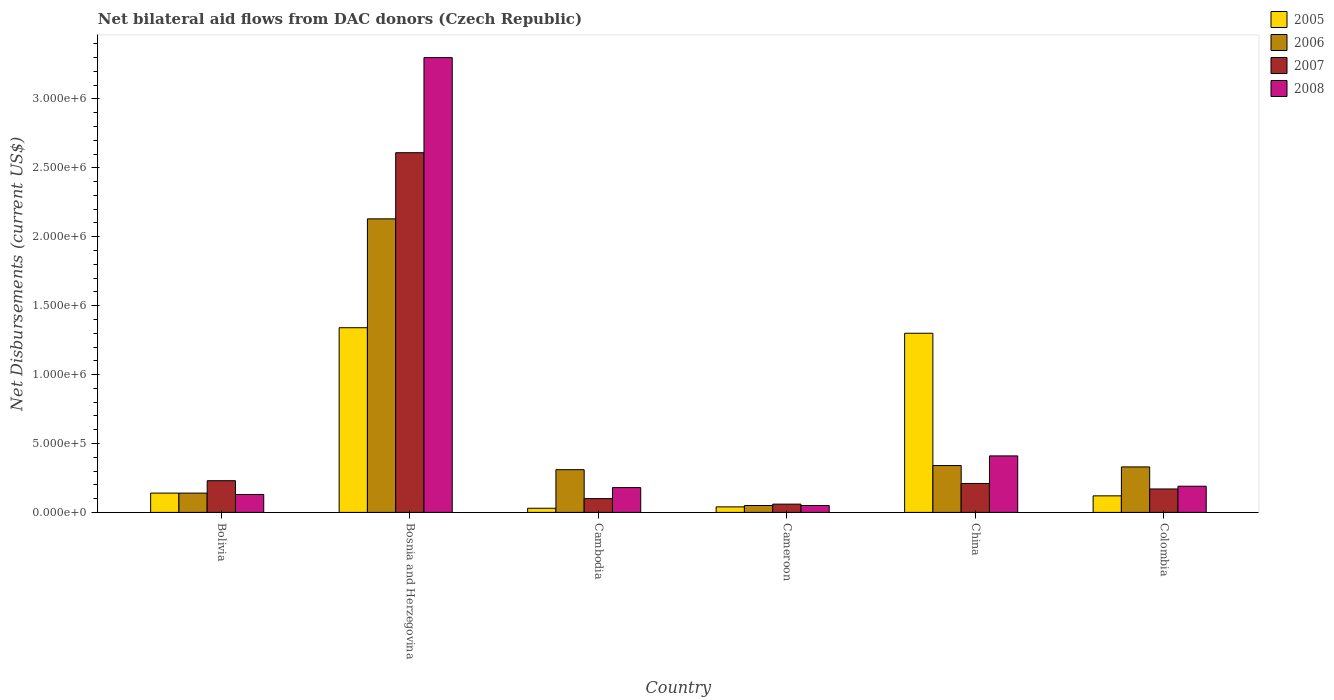How many different coloured bars are there?
Offer a very short reply. 4. How many groups of bars are there?
Your answer should be compact. 6. Are the number of bars per tick equal to the number of legend labels?
Make the answer very short. Yes. Are the number of bars on each tick of the X-axis equal?
Provide a short and direct response. Yes. What is the label of the 2nd group of bars from the left?
Your answer should be compact. Bosnia and Herzegovina. In how many cases, is the number of bars for a given country not equal to the number of legend labels?
Your answer should be compact. 0. What is the net bilateral aid flows in 2007 in Bolivia?
Keep it short and to the point. 2.30e+05. Across all countries, what is the maximum net bilateral aid flows in 2005?
Your answer should be very brief. 1.34e+06. In which country was the net bilateral aid flows in 2006 maximum?
Offer a very short reply. Bosnia and Herzegovina. In which country was the net bilateral aid flows in 2006 minimum?
Offer a very short reply. Cameroon. What is the total net bilateral aid flows in 2007 in the graph?
Offer a terse response. 3.38e+06. What is the difference between the net bilateral aid flows in 2007 in Cambodia and the net bilateral aid flows in 2006 in Bolivia?
Offer a terse response. -4.00e+04. What is the average net bilateral aid flows in 2008 per country?
Provide a short and direct response. 7.10e+05. In how many countries, is the net bilateral aid flows in 2008 greater than 700000 US$?
Provide a short and direct response. 1. What is the ratio of the net bilateral aid flows in 2008 in Cambodia to that in Colombia?
Make the answer very short. 0.95. Is the difference between the net bilateral aid flows in 2008 in Bolivia and Colombia greater than the difference between the net bilateral aid flows in 2007 in Bolivia and Colombia?
Offer a terse response. No. What is the difference between the highest and the second highest net bilateral aid flows in 2006?
Provide a succinct answer. 1.80e+06. What is the difference between the highest and the lowest net bilateral aid flows in 2008?
Offer a terse response. 3.25e+06. In how many countries, is the net bilateral aid flows in 2008 greater than the average net bilateral aid flows in 2008 taken over all countries?
Your answer should be very brief. 1. Is the sum of the net bilateral aid flows in 2006 in Bosnia and Herzegovina and China greater than the maximum net bilateral aid flows in 2007 across all countries?
Provide a short and direct response. No. What does the 3rd bar from the left in Cambodia represents?
Ensure brevity in your answer.  2007. Is it the case that in every country, the sum of the net bilateral aid flows in 2007 and net bilateral aid flows in 2006 is greater than the net bilateral aid flows in 2008?
Keep it short and to the point. Yes. How many bars are there?
Give a very brief answer. 24. Are all the bars in the graph horizontal?
Provide a short and direct response. No. How many countries are there in the graph?
Provide a succinct answer. 6. What is the difference between two consecutive major ticks on the Y-axis?
Make the answer very short. 5.00e+05. Does the graph contain any zero values?
Your response must be concise. No. How many legend labels are there?
Give a very brief answer. 4. How are the legend labels stacked?
Keep it short and to the point. Vertical. What is the title of the graph?
Provide a short and direct response. Net bilateral aid flows from DAC donors (Czech Republic). What is the label or title of the X-axis?
Make the answer very short. Country. What is the label or title of the Y-axis?
Provide a succinct answer. Net Disbursements (current US$). What is the Net Disbursements (current US$) of 2005 in Bolivia?
Make the answer very short. 1.40e+05. What is the Net Disbursements (current US$) of 2007 in Bolivia?
Offer a terse response. 2.30e+05. What is the Net Disbursements (current US$) of 2005 in Bosnia and Herzegovina?
Provide a short and direct response. 1.34e+06. What is the Net Disbursements (current US$) in 2006 in Bosnia and Herzegovina?
Your answer should be compact. 2.13e+06. What is the Net Disbursements (current US$) in 2007 in Bosnia and Herzegovina?
Give a very brief answer. 2.61e+06. What is the Net Disbursements (current US$) in 2008 in Bosnia and Herzegovina?
Ensure brevity in your answer.  3.30e+06. What is the Net Disbursements (current US$) in 2005 in Cambodia?
Provide a succinct answer. 3.00e+04. What is the Net Disbursements (current US$) in 2006 in Cambodia?
Your response must be concise. 3.10e+05. What is the Net Disbursements (current US$) in 2007 in Cambodia?
Ensure brevity in your answer.  1.00e+05. What is the Net Disbursements (current US$) of 2007 in Cameroon?
Your response must be concise. 6.00e+04. What is the Net Disbursements (current US$) in 2008 in Cameroon?
Your answer should be compact. 5.00e+04. What is the Net Disbursements (current US$) in 2005 in China?
Make the answer very short. 1.30e+06. What is the Net Disbursements (current US$) of 2007 in China?
Keep it short and to the point. 2.10e+05. What is the Net Disbursements (current US$) of 2007 in Colombia?
Offer a very short reply. 1.70e+05. What is the Net Disbursements (current US$) of 2008 in Colombia?
Keep it short and to the point. 1.90e+05. Across all countries, what is the maximum Net Disbursements (current US$) of 2005?
Offer a terse response. 1.34e+06. Across all countries, what is the maximum Net Disbursements (current US$) of 2006?
Offer a very short reply. 2.13e+06. Across all countries, what is the maximum Net Disbursements (current US$) of 2007?
Keep it short and to the point. 2.61e+06. Across all countries, what is the maximum Net Disbursements (current US$) of 2008?
Provide a succinct answer. 3.30e+06. Across all countries, what is the minimum Net Disbursements (current US$) in 2006?
Your response must be concise. 5.00e+04. Across all countries, what is the minimum Net Disbursements (current US$) in 2008?
Your response must be concise. 5.00e+04. What is the total Net Disbursements (current US$) in 2005 in the graph?
Offer a terse response. 2.97e+06. What is the total Net Disbursements (current US$) of 2006 in the graph?
Your response must be concise. 3.30e+06. What is the total Net Disbursements (current US$) in 2007 in the graph?
Your response must be concise. 3.38e+06. What is the total Net Disbursements (current US$) of 2008 in the graph?
Your answer should be compact. 4.26e+06. What is the difference between the Net Disbursements (current US$) of 2005 in Bolivia and that in Bosnia and Herzegovina?
Make the answer very short. -1.20e+06. What is the difference between the Net Disbursements (current US$) in 2006 in Bolivia and that in Bosnia and Herzegovina?
Ensure brevity in your answer.  -1.99e+06. What is the difference between the Net Disbursements (current US$) of 2007 in Bolivia and that in Bosnia and Herzegovina?
Your response must be concise. -2.38e+06. What is the difference between the Net Disbursements (current US$) of 2008 in Bolivia and that in Bosnia and Herzegovina?
Your answer should be compact. -3.17e+06. What is the difference between the Net Disbursements (current US$) of 2005 in Bolivia and that in Cambodia?
Your answer should be compact. 1.10e+05. What is the difference between the Net Disbursements (current US$) of 2007 in Bolivia and that in Cambodia?
Provide a short and direct response. 1.30e+05. What is the difference between the Net Disbursements (current US$) of 2008 in Bolivia and that in Cambodia?
Make the answer very short. -5.00e+04. What is the difference between the Net Disbursements (current US$) in 2005 in Bolivia and that in Cameroon?
Keep it short and to the point. 1.00e+05. What is the difference between the Net Disbursements (current US$) in 2008 in Bolivia and that in Cameroon?
Offer a terse response. 8.00e+04. What is the difference between the Net Disbursements (current US$) of 2005 in Bolivia and that in China?
Provide a succinct answer. -1.16e+06. What is the difference between the Net Disbursements (current US$) of 2008 in Bolivia and that in China?
Your answer should be compact. -2.80e+05. What is the difference between the Net Disbursements (current US$) of 2005 in Bolivia and that in Colombia?
Keep it short and to the point. 2.00e+04. What is the difference between the Net Disbursements (current US$) of 2006 in Bolivia and that in Colombia?
Your answer should be compact. -1.90e+05. What is the difference between the Net Disbursements (current US$) in 2005 in Bosnia and Herzegovina and that in Cambodia?
Ensure brevity in your answer.  1.31e+06. What is the difference between the Net Disbursements (current US$) in 2006 in Bosnia and Herzegovina and that in Cambodia?
Your answer should be very brief. 1.82e+06. What is the difference between the Net Disbursements (current US$) of 2007 in Bosnia and Herzegovina and that in Cambodia?
Keep it short and to the point. 2.51e+06. What is the difference between the Net Disbursements (current US$) in 2008 in Bosnia and Herzegovina and that in Cambodia?
Give a very brief answer. 3.12e+06. What is the difference between the Net Disbursements (current US$) of 2005 in Bosnia and Herzegovina and that in Cameroon?
Keep it short and to the point. 1.30e+06. What is the difference between the Net Disbursements (current US$) of 2006 in Bosnia and Herzegovina and that in Cameroon?
Your response must be concise. 2.08e+06. What is the difference between the Net Disbursements (current US$) of 2007 in Bosnia and Herzegovina and that in Cameroon?
Provide a succinct answer. 2.55e+06. What is the difference between the Net Disbursements (current US$) of 2008 in Bosnia and Herzegovina and that in Cameroon?
Give a very brief answer. 3.25e+06. What is the difference between the Net Disbursements (current US$) in 2005 in Bosnia and Herzegovina and that in China?
Your answer should be compact. 4.00e+04. What is the difference between the Net Disbursements (current US$) of 2006 in Bosnia and Herzegovina and that in China?
Offer a terse response. 1.79e+06. What is the difference between the Net Disbursements (current US$) in 2007 in Bosnia and Herzegovina and that in China?
Offer a very short reply. 2.40e+06. What is the difference between the Net Disbursements (current US$) of 2008 in Bosnia and Herzegovina and that in China?
Provide a succinct answer. 2.89e+06. What is the difference between the Net Disbursements (current US$) in 2005 in Bosnia and Herzegovina and that in Colombia?
Ensure brevity in your answer.  1.22e+06. What is the difference between the Net Disbursements (current US$) in 2006 in Bosnia and Herzegovina and that in Colombia?
Provide a succinct answer. 1.80e+06. What is the difference between the Net Disbursements (current US$) in 2007 in Bosnia and Herzegovina and that in Colombia?
Keep it short and to the point. 2.44e+06. What is the difference between the Net Disbursements (current US$) of 2008 in Bosnia and Herzegovina and that in Colombia?
Offer a very short reply. 3.11e+06. What is the difference between the Net Disbursements (current US$) in 2005 in Cambodia and that in Cameroon?
Keep it short and to the point. -10000. What is the difference between the Net Disbursements (current US$) of 2007 in Cambodia and that in Cameroon?
Your answer should be very brief. 4.00e+04. What is the difference between the Net Disbursements (current US$) of 2008 in Cambodia and that in Cameroon?
Your answer should be very brief. 1.30e+05. What is the difference between the Net Disbursements (current US$) of 2005 in Cambodia and that in China?
Your response must be concise. -1.27e+06. What is the difference between the Net Disbursements (current US$) in 2006 in Cambodia and that in China?
Make the answer very short. -3.00e+04. What is the difference between the Net Disbursements (current US$) in 2008 in Cambodia and that in China?
Your answer should be compact. -2.30e+05. What is the difference between the Net Disbursements (current US$) of 2005 in Cambodia and that in Colombia?
Your response must be concise. -9.00e+04. What is the difference between the Net Disbursements (current US$) of 2008 in Cambodia and that in Colombia?
Ensure brevity in your answer.  -10000. What is the difference between the Net Disbursements (current US$) in 2005 in Cameroon and that in China?
Your response must be concise. -1.26e+06. What is the difference between the Net Disbursements (current US$) of 2008 in Cameroon and that in China?
Make the answer very short. -3.60e+05. What is the difference between the Net Disbursements (current US$) of 2006 in Cameroon and that in Colombia?
Ensure brevity in your answer.  -2.80e+05. What is the difference between the Net Disbursements (current US$) in 2007 in Cameroon and that in Colombia?
Keep it short and to the point. -1.10e+05. What is the difference between the Net Disbursements (current US$) in 2005 in China and that in Colombia?
Ensure brevity in your answer.  1.18e+06. What is the difference between the Net Disbursements (current US$) of 2006 in China and that in Colombia?
Your answer should be compact. 10000. What is the difference between the Net Disbursements (current US$) in 2005 in Bolivia and the Net Disbursements (current US$) in 2006 in Bosnia and Herzegovina?
Give a very brief answer. -1.99e+06. What is the difference between the Net Disbursements (current US$) in 2005 in Bolivia and the Net Disbursements (current US$) in 2007 in Bosnia and Herzegovina?
Keep it short and to the point. -2.47e+06. What is the difference between the Net Disbursements (current US$) in 2005 in Bolivia and the Net Disbursements (current US$) in 2008 in Bosnia and Herzegovina?
Your answer should be very brief. -3.16e+06. What is the difference between the Net Disbursements (current US$) of 2006 in Bolivia and the Net Disbursements (current US$) of 2007 in Bosnia and Herzegovina?
Provide a succinct answer. -2.47e+06. What is the difference between the Net Disbursements (current US$) of 2006 in Bolivia and the Net Disbursements (current US$) of 2008 in Bosnia and Herzegovina?
Make the answer very short. -3.16e+06. What is the difference between the Net Disbursements (current US$) of 2007 in Bolivia and the Net Disbursements (current US$) of 2008 in Bosnia and Herzegovina?
Offer a very short reply. -3.07e+06. What is the difference between the Net Disbursements (current US$) in 2005 in Bolivia and the Net Disbursements (current US$) in 2007 in Cambodia?
Keep it short and to the point. 4.00e+04. What is the difference between the Net Disbursements (current US$) of 2005 in Bolivia and the Net Disbursements (current US$) of 2008 in Cambodia?
Make the answer very short. -4.00e+04. What is the difference between the Net Disbursements (current US$) in 2006 in Bolivia and the Net Disbursements (current US$) in 2008 in Cambodia?
Provide a succinct answer. -4.00e+04. What is the difference between the Net Disbursements (current US$) of 2006 in Bolivia and the Net Disbursements (current US$) of 2008 in Cameroon?
Your answer should be compact. 9.00e+04. What is the difference between the Net Disbursements (current US$) in 2007 in Bolivia and the Net Disbursements (current US$) in 2008 in Cameroon?
Your answer should be very brief. 1.80e+05. What is the difference between the Net Disbursements (current US$) of 2005 in Bolivia and the Net Disbursements (current US$) of 2008 in China?
Give a very brief answer. -2.70e+05. What is the difference between the Net Disbursements (current US$) of 2006 in Bolivia and the Net Disbursements (current US$) of 2008 in China?
Your answer should be very brief. -2.70e+05. What is the difference between the Net Disbursements (current US$) of 2007 in Bolivia and the Net Disbursements (current US$) of 2008 in China?
Keep it short and to the point. -1.80e+05. What is the difference between the Net Disbursements (current US$) in 2005 in Bolivia and the Net Disbursements (current US$) in 2006 in Colombia?
Provide a short and direct response. -1.90e+05. What is the difference between the Net Disbursements (current US$) in 2005 in Bolivia and the Net Disbursements (current US$) in 2007 in Colombia?
Offer a very short reply. -3.00e+04. What is the difference between the Net Disbursements (current US$) of 2005 in Bolivia and the Net Disbursements (current US$) of 2008 in Colombia?
Your answer should be compact. -5.00e+04. What is the difference between the Net Disbursements (current US$) in 2005 in Bosnia and Herzegovina and the Net Disbursements (current US$) in 2006 in Cambodia?
Provide a succinct answer. 1.03e+06. What is the difference between the Net Disbursements (current US$) of 2005 in Bosnia and Herzegovina and the Net Disbursements (current US$) of 2007 in Cambodia?
Offer a very short reply. 1.24e+06. What is the difference between the Net Disbursements (current US$) in 2005 in Bosnia and Herzegovina and the Net Disbursements (current US$) in 2008 in Cambodia?
Offer a terse response. 1.16e+06. What is the difference between the Net Disbursements (current US$) in 2006 in Bosnia and Herzegovina and the Net Disbursements (current US$) in 2007 in Cambodia?
Your answer should be compact. 2.03e+06. What is the difference between the Net Disbursements (current US$) in 2006 in Bosnia and Herzegovina and the Net Disbursements (current US$) in 2008 in Cambodia?
Give a very brief answer. 1.95e+06. What is the difference between the Net Disbursements (current US$) in 2007 in Bosnia and Herzegovina and the Net Disbursements (current US$) in 2008 in Cambodia?
Provide a succinct answer. 2.43e+06. What is the difference between the Net Disbursements (current US$) in 2005 in Bosnia and Herzegovina and the Net Disbursements (current US$) in 2006 in Cameroon?
Your answer should be very brief. 1.29e+06. What is the difference between the Net Disbursements (current US$) in 2005 in Bosnia and Herzegovina and the Net Disbursements (current US$) in 2007 in Cameroon?
Your answer should be compact. 1.28e+06. What is the difference between the Net Disbursements (current US$) in 2005 in Bosnia and Herzegovina and the Net Disbursements (current US$) in 2008 in Cameroon?
Your response must be concise. 1.29e+06. What is the difference between the Net Disbursements (current US$) in 2006 in Bosnia and Herzegovina and the Net Disbursements (current US$) in 2007 in Cameroon?
Make the answer very short. 2.07e+06. What is the difference between the Net Disbursements (current US$) of 2006 in Bosnia and Herzegovina and the Net Disbursements (current US$) of 2008 in Cameroon?
Your response must be concise. 2.08e+06. What is the difference between the Net Disbursements (current US$) of 2007 in Bosnia and Herzegovina and the Net Disbursements (current US$) of 2008 in Cameroon?
Offer a terse response. 2.56e+06. What is the difference between the Net Disbursements (current US$) in 2005 in Bosnia and Herzegovina and the Net Disbursements (current US$) in 2006 in China?
Make the answer very short. 1.00e+06. What is the difference between the Net Disbursements (current US$) of 2005 in Bosnia and Herzegovina and the Net Disbursements (current US$) of 2007 in China?
Your answer should be compact. 1.13e+06. What is the difference between the Net Disbursements (current US$) in 2005 in Bosnia and Herzegovina and the Net Disbursements (current US$) in 2008 in China?
Your answer should be very brief. 9.30e+05. What is the difference between the Net Disbursements (current US$) of 2006 in Bosnia and Herzegovina and the Net Disbursements (current US$) of 2007 in China?
Your answer should be compact. 1.92e+06. What is the difference between the Net Disbursements (current US$) of 2006 in Bosnia and Herzegovina and the Net Disbursements (current US$) of 2008 in China?
Keep it short and to the point. 1.72e+06. What is the difference between the Net Disbursements (current US$) of 2007 in Bosnia and Herzegovina and the Net Disbursements (current US$) of 2008 in China?
Your answer should be very brief. 2.20e+06. What is the difference between the Net Disbursements (current US$) of 2005 in Bosnia and Herzegovina and the Net Disbursements (current US$) of 2006 in Colombia?
Give a very brief answer. 1.01e+06. What is the difference between the Net Disbursements (current US$) of 2005 in Bosnia and Herzegovina and the Net Disbursements (current US$) of 2007 in Colombia?
Make the answer very short. 1.17e+06. What is the difference between the Net Disbursements (current US$) in 2005 in Bosnia and Herzegovina and the Net Disbursements (current US$) in 2008 in Colombia?
Give a very brief answer. 1.15e+06. What is the difference between the Net Disbursements (current US$) of 2006 in Bosnia and Herzegovina and the Net Disbursements (current US$) of 2007 in Colombia?
Give a very brief answer. 1.96e+06. What is the difference between the Net Disbursements (current US$) in 2006 in Bosnia and Herzegovina and the Net Disbursements (current US$) in 2008 in Colombia?
Your answer should be very brief. 1.94e+06. What is the difference between the Net Disbursements (current US$) of 2007 in Bosnia and Herzegovina and the Net Disbursements (current US$) of 2008 in Colombia?
Offer a terse response. 2.42e+06. What is the difference between the Net Disbursements (current US$) in 2005 in Cambodia and the Net Disbursements (current US$) in 2006 in Cameroon?
Provide a short and direct response. -2.00e+04. What is the difference between the Net Disbursements (current US$) of 2005 in Cambodia and the Net Disbursements (current US$) of 2007 in Cameroon?
Provide a short and direct response. -3.00e+04. What is the difference between the Net Disbursements (current US$) of 2006 in Cambodia and the Net Disbursements (current US$) of 2007 in Cameroon?
Offer a terse response. 2.50e+05. What is the difference between the Net Disbursements (current US$) in 2006 in Cambodia and the Net Disbursements (current US$) in 2008 in Cameroon?
Your answer should be very brief. 2.60e+05. What is the difference between the Net Disbursements (current US$) in 2005 in Cambodia and the Net Disbursements (current US$) in 2006 in China?
Keep it short and to the point. -3.10e+05. What is the difference between the Net Disbursements (current US$) in 2005 in Cambodia and the Net Disbursements (current US$) in 2008 in China?
Provide a short and direct response. -3.80e+05. What is the difference between the Net Disbursements (current US$) of 2006 in Cambodia and the Net Disbursements (current US$) of 2007 in China?
Your answer should be compact. 1.00e+05. What is the difference between the Net Disbursements (current US$) of 2006 in Cambodia and the Net Disbursements (current US$) of 2008 in China?
Keep it short and to the point. -1.00e+05. What is the difference between the Net Disbursements (current US$) in 2007 in Cambodia and the Net Disbursements (current US$) in 2008 in China?
Provide a short and direct response. -3.10e+05. What is the difference between the Net Disbursements (current US$) in 2005 in Cambodia and the Net Disbursements (current US$) in 2006 in Colombia?
Provide a short and direct response. -3.00e+05. What is the difference between the Net Disbursements (current US$) in 2005 in Cambodia and the Net Disbursements (current US$) in 2007 in Colombia?
Make the answer very short. -1.40e+05. What is the difference between the Net Disbursements (current US$) of 2006 in Cambodia and the Net Disbursements (current US$) of 2007 in Colombia?
Make the answer very short. 1.40e+05. What is the difference between the Net Disbursements (current US$) in 2005 in Cameroon and the Net Disbursements (current US$) in 2007 in China?
Your response must be concise. -1.70e+05. What is the difference between the Net Disbursements (current US$) in 2005 in Cameroon and the Net Disbursements (current US$) in 2008 in China?
Your response must be concise. -3.70e+05. What is the difference between the Net Disbursements (current US$) of 2006 in Cameroon and the Net Disbursements (current US$) of 2007 in China?
Provide a succinct answer. -1.60e+05. What is the difference between the Net Disbursements (current US$) in 2006 in Cameroon and the Net Disbursements (current US$) in 2008 in China?
Your answer should be very brief. -3.60e+05. What is the difference between the Net Disbursements (current US$) of 2007 in Cameroon and the Net Disbursements (current US$) of 2008 in China?
Your response must be concise. -3.50e+05. What is the difference between the Net Disbursements (current US$) in 2005 in Cameroon and the Net Disbursements (current US$) in 2006 in Colombia?
Your answer should be very brief. -2.90e+05. What is the difference between the Net Disbursements (current US$) in 2005 in China and the Net Disbursements (current US$) in 2006 in Colombia?
Provide a succinct answer. 9.70e+05. What is the difference between the Net Disbursements (current US$) of 2005 in China and the Net Disbursements (current US$) of 2007 in Colombia?
Make the answer very short. 1.13e+06. What is the difference between the Net Disbursements (current US$) in 2005 in China and the Net Disbursements (current US$) in 2008 in Colombia?
Provide a succinct answer. 1.11e+06. What is the difference between the Net Disbursements (current US$) in 2006 in China and the Net Disbursements (current US$) in 2008 in Colombia?
Give a very brief answer. 1.50e+05. What is the average Net Disbursements (current US$) of 2005 per country?
Your answer should be compact. 4.95e+05. What is the average Net Disbursements (current US$) of 2006 per country?
Provide a succinct answer. 5.50e+05. What is the average Net Disbursements (current US$) of 2007 per country?
Ensure brevity in your answer.  5.63e+05. What is the average Net Disbursements (current US$) of 2008 per country?
Keep it short and to the point. 7.10e+05. What is the difference between the Net Disbursements (current US$) of 2005 and Net Disbursements (current US$) of 2006 in Bolivia?
Ensure brevity in your answer.  0. What is the difference between the Net Disbursements (current US$) of 2005 and Net Disbursements (current US$) of 2007 in Bolivia?
Provide a short and direct response. -9.00e+04. What is the difference between the Net Disbursements (current US$) of 2005 and Net Disbursements (current US$) of 2006 in Bosnia and Herzegovina?
Ensure brevity in your answer.  -7.90e+05. What is the difference between the Net Disbursements (current US$) of 2005 and Net Disbursements (current US$) of 2007 in Bosnia and Herzegovina?
Provide a short and direct response. -1.27e+06. What is the difference between the Net Disbursements (current US$) in 2005 and Net Disbursements (current US$) in 2008 in Bosnia and Herzegovina?
Your response must be concise. -1.96e+06. What is the difference between the Net Disbursements (current US$) of 2006 and Net Disbursements (current US$) of 2007 in Bosnia and Herzegovina?
Keep it short and to the point. -4.80e+05. What is the difference between the Net Disbursements (current US$) in 2006 and Net Disbursements (current US$) in 2008 in Bosnia and Herzegovina?
Offer a terse response. -1.17e+06. What is the difference between the Net Disbursements (current US$) in 2007 and Net Disbursements (current US$) in 2008 in Bosnia and Herzegovina?
Offer a terse response. -6.90e+05. What is the difference between the Net Disbursements (current US$) in 2005 and Net Disbursements (current US$) in 2006 in Cambodia?
Keep it short and to the point. -2.80e+05. What is the difference between the Net Disbursements (current US$) of 2005 and Net Disbursements (current US$) of 2007 in Cambodia?
Your answer should be very brief. -7.00e+04. What is the difference between the Net Disbursements (current US$) in 2006 and Net Disbursements (current US$) in 2008 in Cambodia?
Make the answer very short. 1.30e+05. What is the difference between the Net Disbursements (current US$) in 2007 and Net Disbursements (current US$) in 2008 in Cambodia?
Provide a succinct answer. -8.00e+04. What is the difference between the Net Disbursements (current US$) in 2005 and Net Disbursements (current US$) in 2006 in Cameroon?
Provide a succinct answer. -10000. What is the difference between the Net Disbursements (current US$) in 2005 and Net Disbursements (current US$) in 2007 in Cameroon?
Your answer should be compact. -2.00e+04. What is the difference between the Net Disbursements (current US$) in 2005 and Net Disbursements (current US$) in 2006 in China?
Your answer should be very brief. 9.60e+05. What is the difference between the Net Disbursements (current US$) of 2005 and Net Disbursements (current US$) of 2007 in China?
Your answer should be very brief. 1.09e+06. What is the difference between the Net Disbursements (current US$) in 2005 and Net Disbursements (current US$) in 2008 in China?
Your answer should be very brief. 8.90e+05. What is the difference between the Net Disbursements (current US$) of 2005 and Net Disbursements (current US$) of 2006 in Colombia?
Offer a very short reply. -2.10e+05. What is the difference between the Net Disbursements (current US$) of 2005 and Net Disbursements (current US$) of 2008 in Colombia?
Your answer should be very brief. -7.00e+04. What is the difference between the Net Disbursements (current US$) of 2006 and Net Disbursements (current US$) of 2007 in Colombia?
Offer a terse response. 1.60e+05. What is the difference between the Net Disbursements (current US$) in 2007 and Net Disbursements (current US$) in 2008 in Colombia?
Offer a terse response. -2.00e+04. What is the ratio of the Net Disbursements (current US$) of 2005 in Bolivia to that in Bosnia and Herzegovina?
Your response must be concise. 0.1. What is the ratio of the Net Disbursements (current US$) of 2006 in Bolivia to that in Bosnia and Herzegovina?
Offer a very short reply. 0.07. What is the ratio of the Net Disbursements (current US$) of 2007 in Bolivia to that in Bosnia and Herzegovina?
Your answer should be compact. 0.09. What is the ratio of the Net Disbursements (current US$) of 2008 in Bolivia to that in Bosnia and Herzegovina?
Your response must be concise. 0.04. What is the ratio of the Net Disbursements (current US$) of 2005 in Bolivia to that in Cambodia?
Provide a short and direct response. 4.67. What is the ratio of the Net Disbursements (current US$) of 2006 in Bolivia to that in Cambodia?
Your answer should be very brief. 0.45. What is the ratio of the Net Disbursements (current US$) in 2007 in Bolivia to that in Cambodia?
Your answer should be compact. 2.3. What is the ratio of the Net Disbursements (current US$) of 2008 in Bolivia to that in Cambodia?
Offer a very short reply. 0.72. What is the ratio of the Net Disbursements (current US$) of 2005 in Bolivia to that in Cameroon?
Your response must be concise. 3.5. What is the ratio of the Net Disbursements (current US$) in 2006 in Bolivia to that in Cameroon?
Your answer should be compact. 2.8. What is the ratio of the Net Disbursements (current US$) of 2007 in Bolivia to that in Cameroon?
Your answer should be compact. 3.83. What is the ratio of the Net Disbursements (current US$) of 2005 in Bolivia to that in China?
Ensure brevity in your answer.  0.11. What is the ratio of the Net Disbursements (current US$) in 2006 in Bolivia to that in China?
Give a very brief answer. 0.41. What is the ratio of the Net Disbursements (current US$) in 2007 in Bolivia to that in China?
Give a very brief answer. 1.1. What is the ratio of the Net Disbursements (current US$) in 2008 in Bolivia to that in China?
Your answer should be compact. 0.32. What is the ratio of the Net Disbursements (current US$) in 2005 in Bolivia to that in Colombia?
Give a very brief answer. 1.17. What is the ratio of the Net Disbursements (current US$) in 2006 in Bolivia to that in Colombia?
Ensure brevity in your answer.  0.42. What is the ratio of the Net Disbursements (current US$) of 2007 in Bolivia to that in Colombia?
Give a very brief answer. 1.35. What is the ratio of the Net Disbursements (current US$) in 2008 in Bolivia to that in Colombia?
Your answer should be very brief. 0.68. What is the ratio of the Net Disbursements (current US$) of 2005 in Bosnia and Herzegovina to that in Cambodia?
Make the answer very short. 44.67. What is the ratio of the Net Disbursements (current US$) of 2006 in Bosnia and Herzegovina to that in Cambodia?
Provide a succinct answer. 6.87. What is the ratio of the Net Disbursements (current US$) of 2007 in Bosnia and Herzegovina to that in Cambodia?
Ensure brevity in your answer.  26.1. What is the ratio of the Net Disbursements (current US$) in 2008 in Bosnia and Herzegovina to that in Cambodia?
Keep it short and to the point. 18.33. What is the ratio of the Net Disbursements (current US$) in 2005 in Bosnia and Herzegovina to that in Cameroon?
Keep it short and to the point. 33.5. What is the ratio of the Net Disbursements (current US$) in 2006 in Bosnia and Herzegovina to that in Cameroon?
Offer a very short reply. 42.6. What is the ratio of the Net Disbursements (current US$) of 2007 in Bosnia and Herzegovina to that in Cameroon?
Your answer should be compact. 43.5. What is the ratio of the Net Disbursements (current US$) of 2005 in Bosnia and Herzegovina to that in China?
Offer a very short reply. 1.03. What is the ratio of the Net Disbursements (current US$) in 2006 in Bosnia and Herzegovina to that in China?
Offer a very short reply. 6.26. What is the ratio of the Net Disbursements (current US$) in 2007 in Bosnia and Herzegovina to that in China?
Your answer should be compact. 12.43. What is the ratio of the Net Disbursements (current US$) in 2008 in Bosnia and Herzegovina to that in China?
Your answer should be compact. 8.05. What is the ratio of the Net Disbursements (current US$) of 2005 in Bosnia and Herzegovina to that in Colombia?
Offer a very short reply. 11.17. What is the ratio of the Net Disbursements (current US$) of 2006 in Bosnia and Herzegovina to that in Colombia?
Your response must be concise. 6.45. What is the ratio of the Net Disbursements (current US$) of 2007 in Bosnia and Herzegovina to that in Colombia?
Offer a terse response. 15.35. What is the ratio of the Net Disbursements (current US$) of 2008 in Bosnia and Herzegovina to that in Colombia?
Provide a short and direct response. 17.37. What is the ratio of the Net Disbursements (current US$) of 2008 in Cambodia to that in Cameroon?
Your answer should be very brief. 3.6. What is the ratio of the Net Disbursements (current US$) of 2005 in Cambodia to that in China?
Give a very brief answer. 0.02. What is the ratio of the Net Disbursements (current US$) of 2006 in Cambodia to that in China?
Provide a succinct answer. 0.91. What is the ratio of the Net Disbursements (current US$) of 2007 in Cambodia to that in China?
Provide a short and direct response. 0.48. What is the ratio of the Net Disbursements (current US$) of 2008 in Cambodia to that in China?
Offer a terse response. 0.44. What is the ratio of the Net Disbursements (current US$) of 2006 in Cambodia to that in Colombia?
Your answer should be very brief. 0.94. What is the ratio of the Net Disbursements (current US$) in 2007 in Cambodia to that in Colombia?
Give a very brief answer. 0.59. What is the ratio of the Net Disbursements (current US$) of 2005 in Cameroon to that in China?
Provide a succinct answer. 0.03. What is the ratio of the Net Disbursements (current US$) in 2006 in Cameroon to that in China?
Your answer should be compact. 0.15. What is the ratio of the Net Disbursements (current US$) of 2007 in Cameroon to that in China?
Your response must be concise. 0.29. What is the ratio of the Net Disbursements (current US$) of 2008 in Cameroon to that in China?
Your response must be concise. 0.12. What is the ratio of the Net Disbursements (current US$) of 2005 in Cameroon to that in Colombia?
Ensure brevity in your answer.  0.33. What is the ratio of the Net Disbursements (current US$) in 2006 in Cameroon to that in Colombia?
Ensure brevity in your answer.  0.15. What is the ratio of the Net Disbursements (current US$) of 2007 in Cameroon to that in Colombia?
Provide a short and direct response. 0.35. What is the ratio of the Net Disbursements (current US$) of 2008 in Cameroon to that in Colombia?
Make the answer very short. 0.26. What is the ratio of the Net Disbursements (current US$) in 2005 in China to that in Colombia?
Provide a succinct answer. 10.83. What is the ratio of the Net Disbursements (current US$) in 2006 in China to that in Colombia?
Your response must be concise. 1.03. What is the ratio of the Net Disbursements (current US$) of 2007 in China to that in Colombia?
Make the answer very short. 1.24. What is the ratio of the Net Disbursements (current US$) in 2008 in China to that in Colombia?
Your answer should be compact. 2.16. What is the difference between the highest and the second highest Net Disbursements (current US$) in 2006?
Your response must be concise. 1.79e+06. What is the difference between the highest and the second highest Net Disbursements (current US$) of 2007?
Provide a short and direct response. 2.38e+06. What is the difference between the highest and the second highest Net Disbursements (current US$) of 2008?
Provide a succinct answer. 2.89e+06. What is the difference between the highest and the lowest Net Disbursements (current US$) in 2005?
Your answer should be compact. 1.31e+06. What is the difference between the highest and the lowest Net Disbursements (current US$) in 2006?
Your response must be concise. 2.08e+06. What is the difference between the highest and the lowest Net Disbursements (current US$) of 2007?
Offer a very short reply. 2.55e+06. What is the difference between the highest and the lowest Net Disbursements (current US$) of 2008?
Offer a terse response. 3.25e+06. 